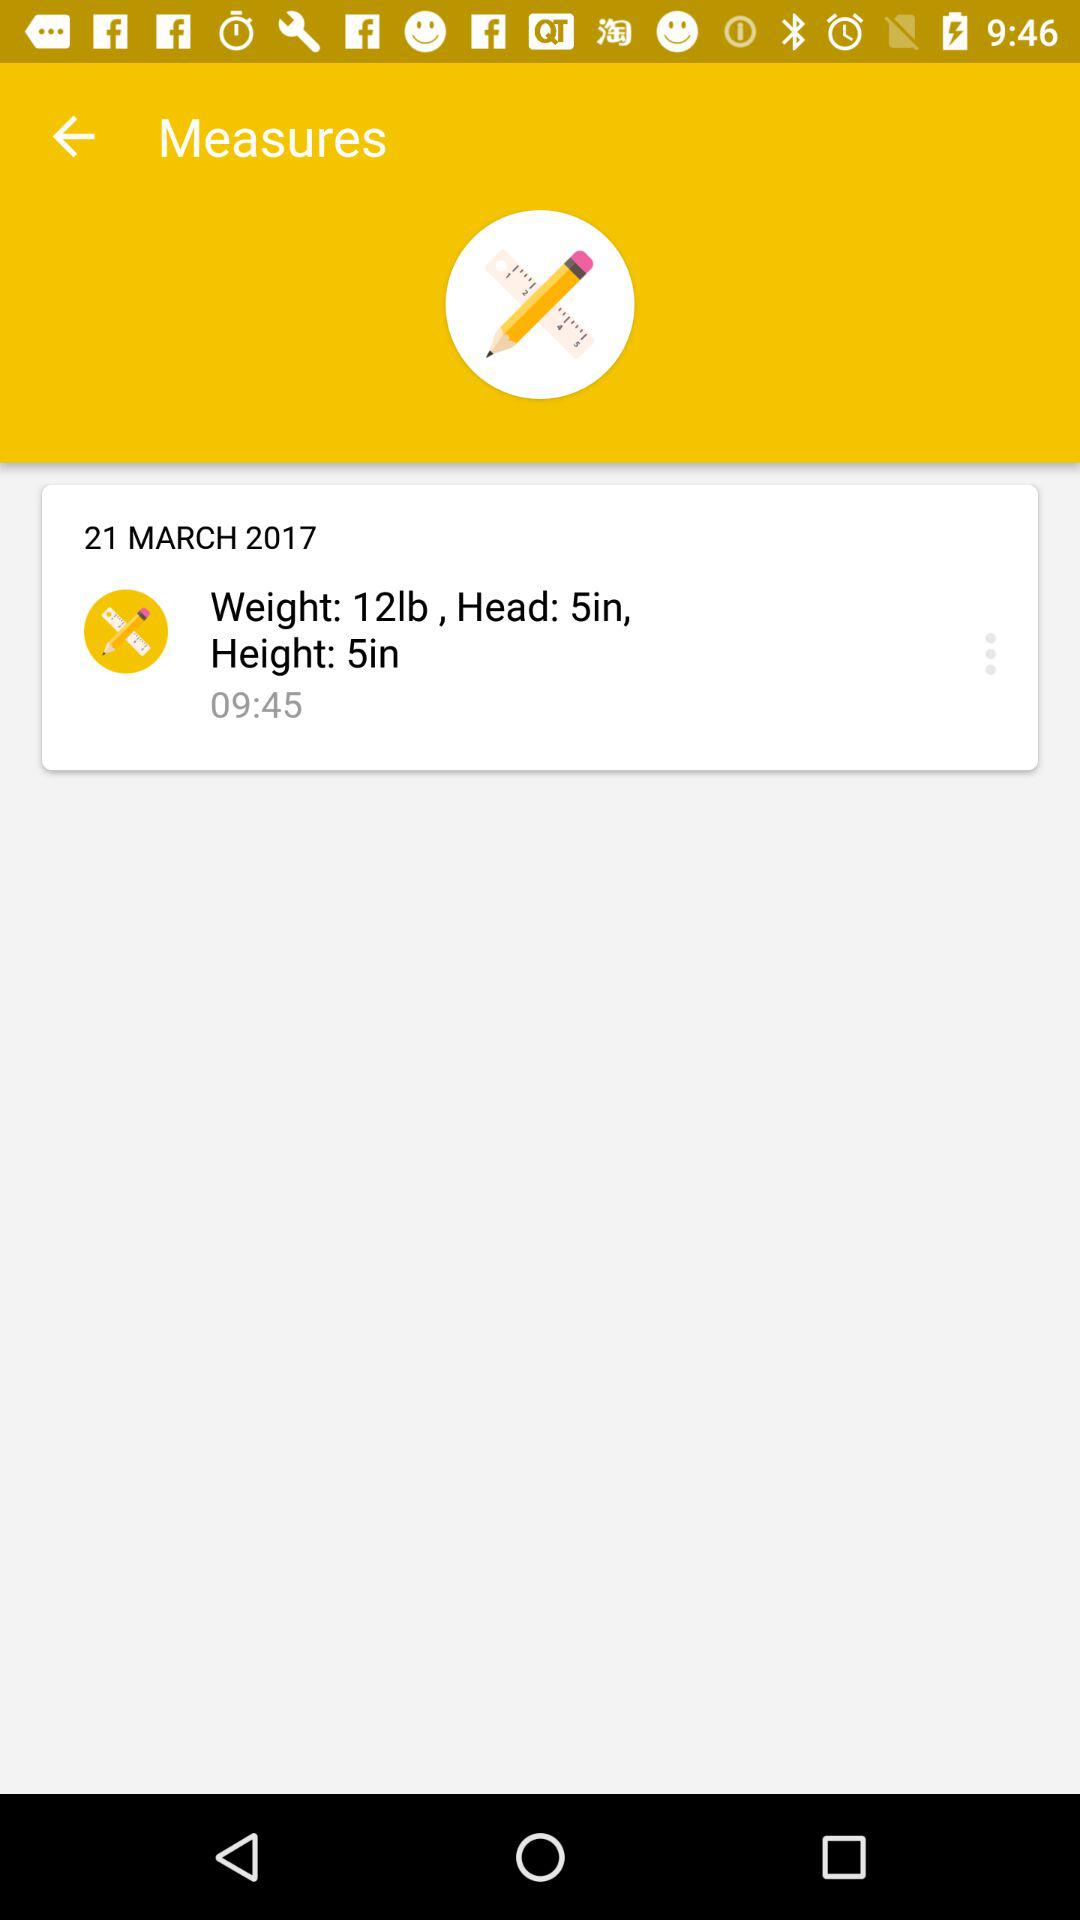What is the height? The height is 5 inches. 